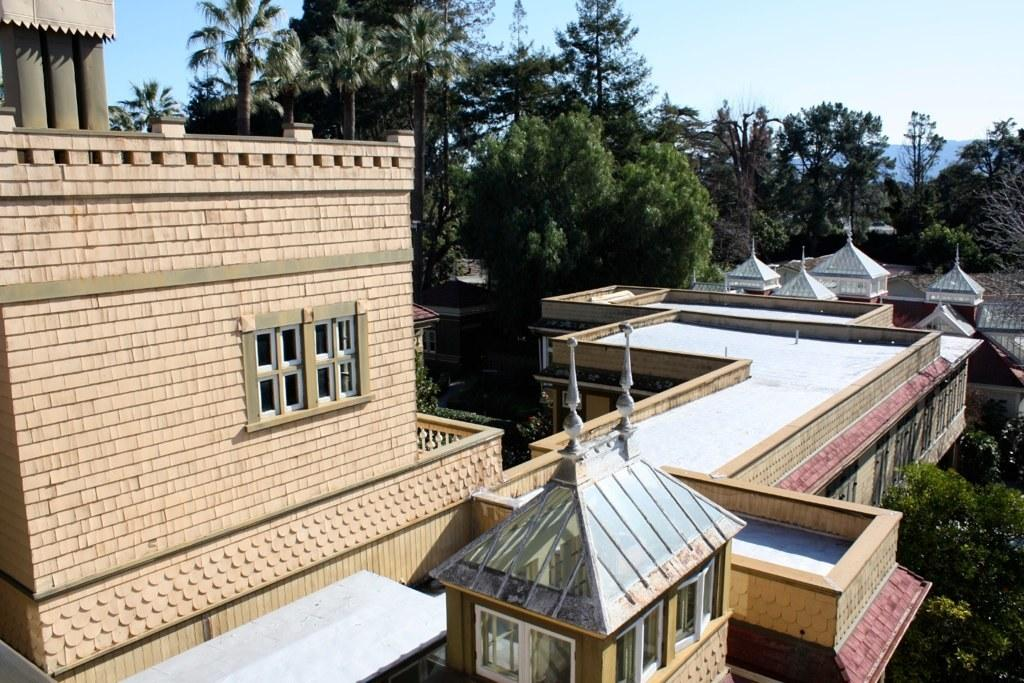What type of structure is present in the image? There is a building in the image. What other natural elements can be seen in the image? There are trees in the image. What is visible at the top of the image? The sky is visible at the top of the image. What type of teeth can be seen in the image? There are no teeth visible in the image. What invention is being demonstrated in the image? There is no invention being demonstrated in the image. 